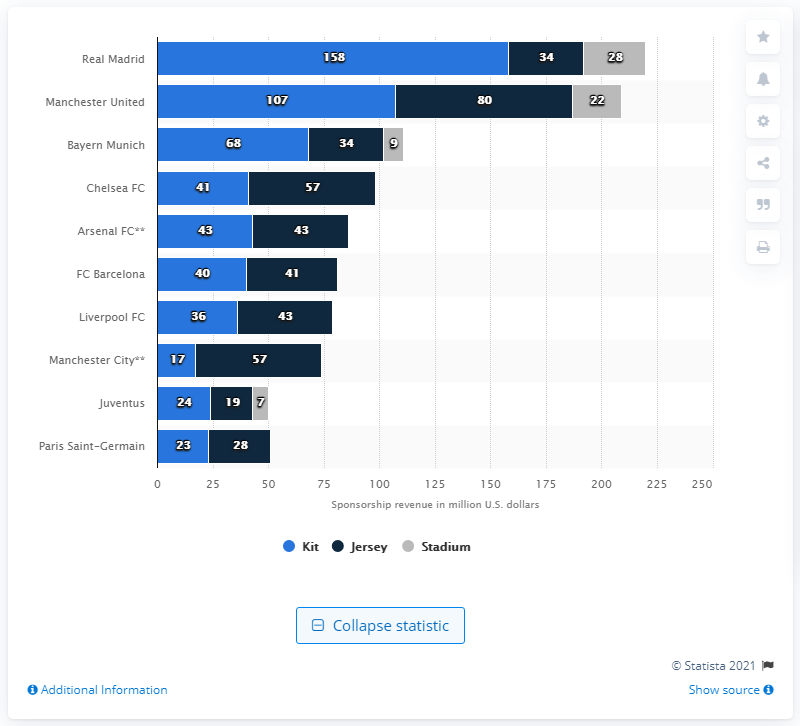Outline some significant characteristics in this image. The total sponsorship for Manchester City is 209. Real Madrid had the most valuable sponsorship deals in the 2015/2016 season. Real Madrid has the highest average annual sponsorship revenue among all teams. 